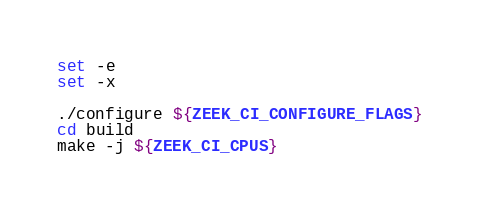Convert code to text. <code><loc_0><loc_0><loc_500><loc_500><_Bash_>set -e
set -x

./configure ${ZEEK_CI_CONFIGURE_FLAGS}
cd build
make -j ${ZEEK_CI_CPUS}
</code> 